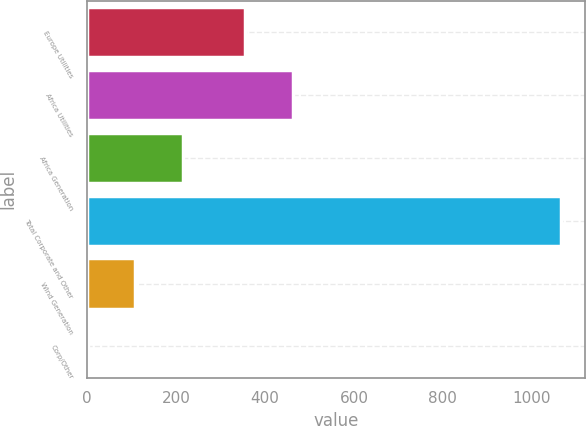Convert chart. <chart><loc_0><loc_0><loc_500><loc_500><bar_chart><fcel>Europe Utilities<fcel>Africa Utilities<fcel>Africa Generation<fcel>Total Corporate and Other<fcel>Wind Generation<fcel>Corp/Other<nl><fcel>356<fcel>462.4<fcel>214.8<fcel>1066<fcel>108.4<fcel>2<nl></chart> 